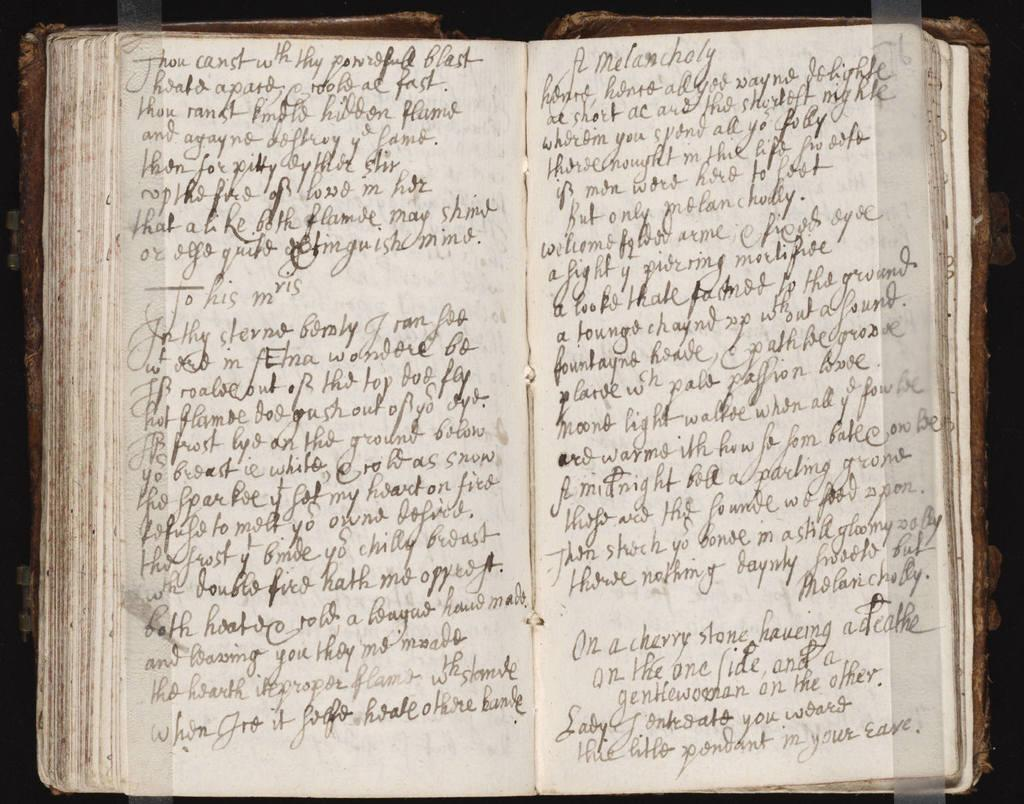<image>
Write a terse but informative summary of the picture. A notebook page is filled with handwritten text and the first word is thou. 